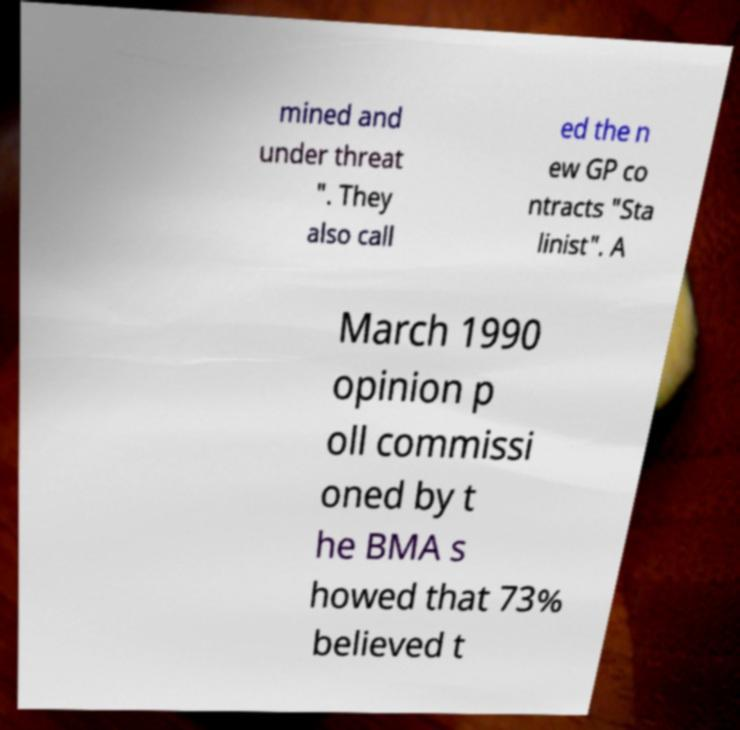There's text embedded in this image that I need extracted. Can you transcribe it verbatim? mined and under threat ". They also call ed the n ew GP co ntracts "Sta linist". A March 1990 opinion p oll commissi oned by t he BMA s howed that 73% believed t 